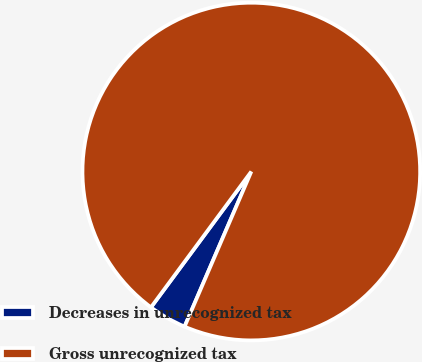<chart> <loc_0><loc_0><loc_500><loc_500><pie_chart><fcel>Decreases in unrecognized tax<fcel>Gross unrecognized tax<nl><fcel>3.66%<fcel>96.34%<nl></chart> 